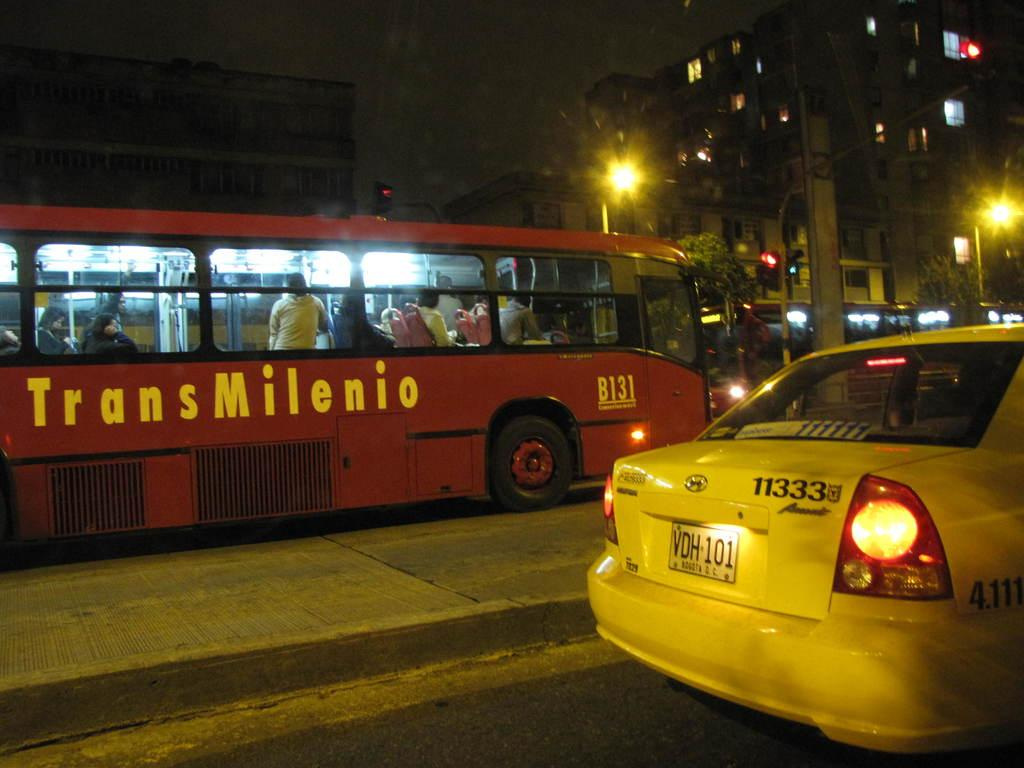<image>
Give a short and clear explanation of the subsequent image. TransMilenio Bus # B131 and a Taxi Cab # 11333 are both on the road. 